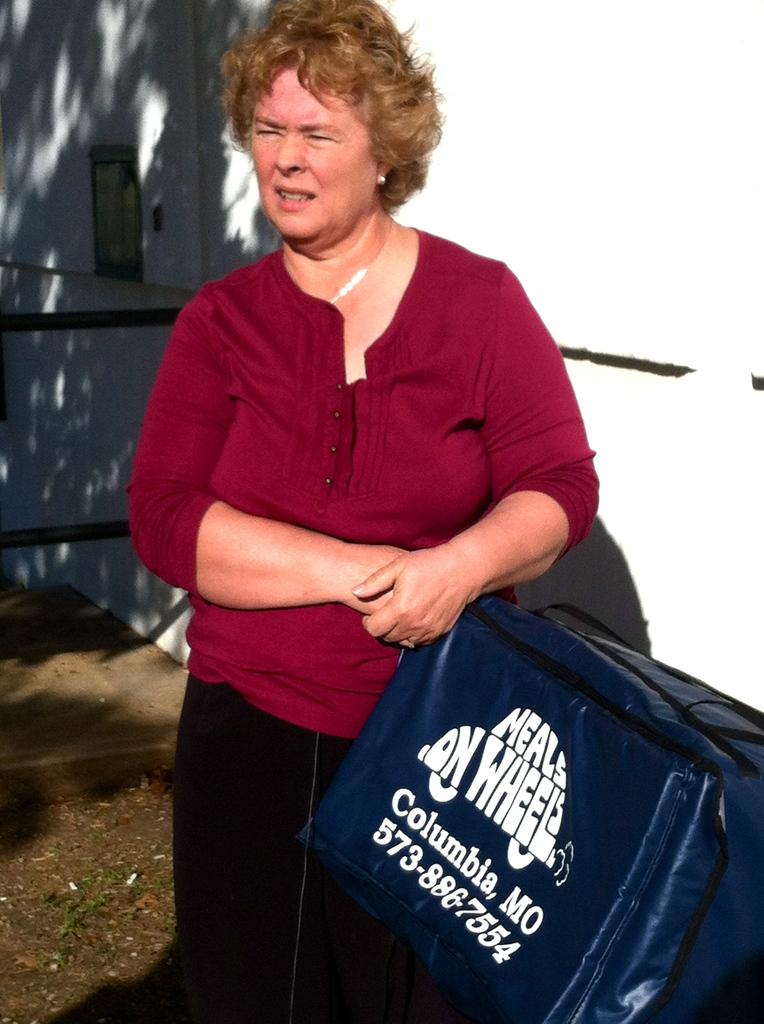Who is present in the image? There is a woman in the image. What is the woman holding in the image? The woman is holding a bag. What can be seen in the background of the image? There is a wall visible in the background of the image. What type of industry can be seen in the background of the image? There is no industry visible in the background of the image; it only features a wall. 